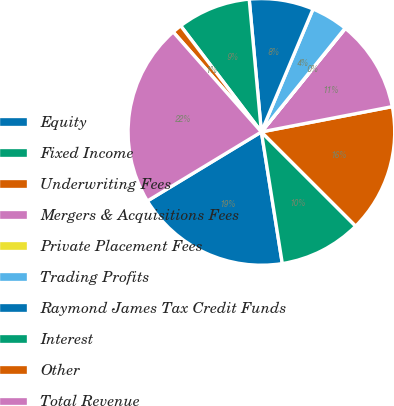Convert chart. <chart><loc_0><loc_0><loc_500><loc_500><pie_chart><fcel>Equity<fcel>Fixed Income<fcel>Underwriting Fees<fcel>Mergers & Acquisitions Fees<fcel>Private Placement Fees<fcel>Trading Profits<fcel>Raymond James Tax Credit Funds<fcel>Interest<fcel>Other<fcel>Total Revenue<nl><fcel>18.84%<fcel>10.0%<fcel>15.53%<fcel>11.11%<fcel>0.05%<fcel>4.47%<fcel>7.79%<fcel>8.89%<fcel>1.16%<fcel>22.16%<nl></chart> 